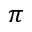<formula> <loc_0><loc_0><loc_500><loc_500>\pi</formula> 